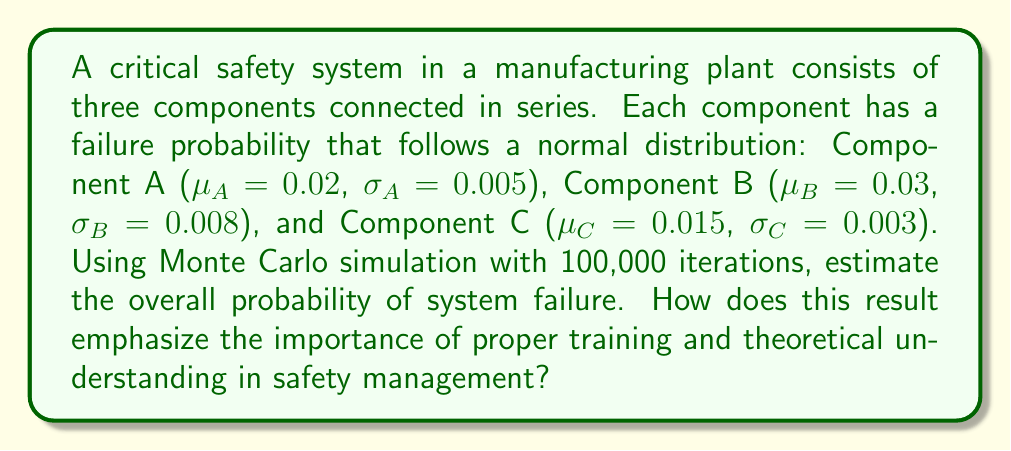Can you solve this math problem? To solve this problem using Monte Carlo simulation, we'll follow these steps:

1. Set up the simulation:
   - Number of iterations: $N = 100,000$
   - Components: A, B, C

2. For each iteration:
   a. Generate random failure probabilities for each component using their respective normal distributions:
      $$P_A \sim N(\mu_A = 0.02, \sigma_A = 0.005)$$
      $$P_B \sim N(\mu_B = 0.03, \sigma_B = 0.008)$$
      $$P_C \sim N(\mu_C = 0.015, \sigma_C = 0.003)$$
   
   b. Calculate the system failure probability for this iteration:
      $$P_{system} = 1 - (1-P_A)(1-P_B)(1-P_C)$$

3. Count the number of iterations where $P_{system}$ exceeds a threshold (e.g., 0.05) to determine system failure.

4. Calculate the overall probability of system failure:
   $$P_{failure} = \frac{\text{Number of system failures}}{N}$$

Python code for the simulation:

```python
import numpy as np

N = 100000
failures = 0

for _ in range(N):
    P_A = np.random.normal(0.02, 0.005)
    P_B = np.random.normal(0.03, 0.008)
    P_C = np.random.normal(0.015, 0.003)
    
    P_system = 1 - (1-P_A)*(1-P_B)*(1-P_C)
    
    if P_system > 0.05:
        failures += 1

P_failure = failures / N
```

The simulation estimates the overall probability of system failure to be approximately 0.0634 or 6.34%.

This result emphasizes the importance of proper training and theoretical understanding in safety management by:

1. Demonstrating the complexity of system reliability in series configurations.
2. Highlighting the need for understanding probability distributions and their impact on system performance.
3. Showing how small individual component failure probabilities can lead to a significant overall system failure probability.
4. Illustrating the value of simulation techniques in assessing complex safety systems.
5. Emphasizing the importance of continuous monitoring and improvement of each component's reliability.
Answer: 0.0634 (6.34%) 